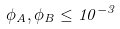Convert formula to latex. <formula><loc_0><loc_0><loc_500><loc_500>\phi _ { A } , \phi _ { B } \leq 1 0 ^ { - 3 }</formula> 